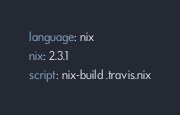Convert code to text. <code><loc_0><loc_0><loc_500><loc_500><_YAML_>language: nix
nix: 2.3.1
script: nix-build .travis.nix
</code> 